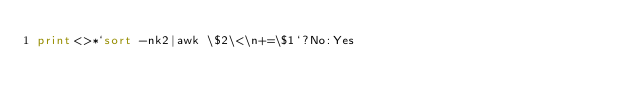Convert code to text. <code><loc_0><loc_0><loc_500><loc_500><_Perl_>print<>*`sort -nk2|awk \$2\<\n+=\$1`?No:Yes</code> 